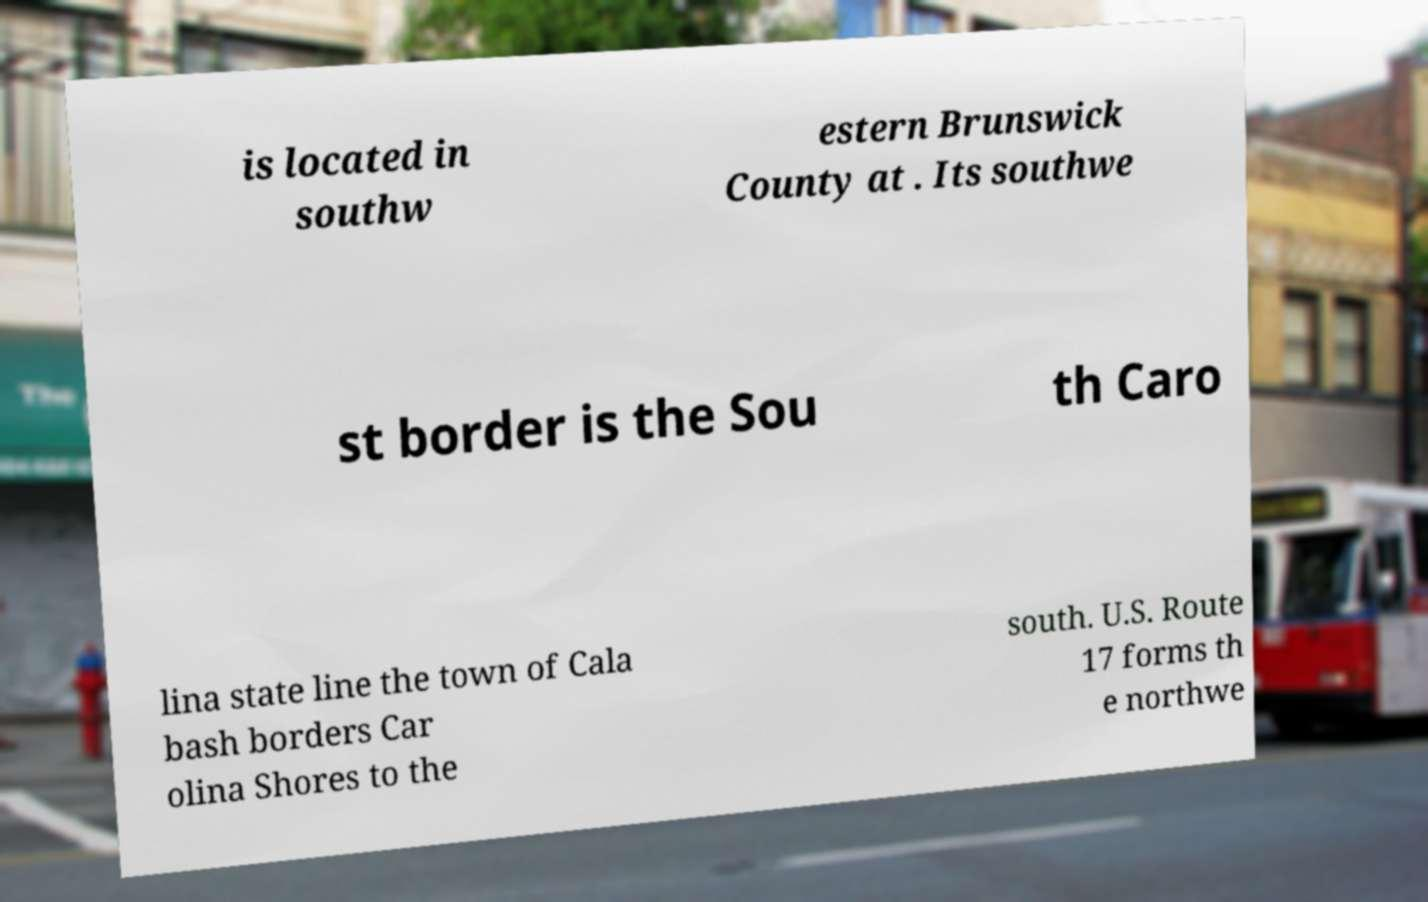I need the written content from this picture converted into text. Can you do that? is located in southw estern Brunswick County at . Its southwe st border is the Sou th Caro lina state line the town of Cala bash borders Car olina Shores to the south. U.S. Route 17 forms th e northwe 